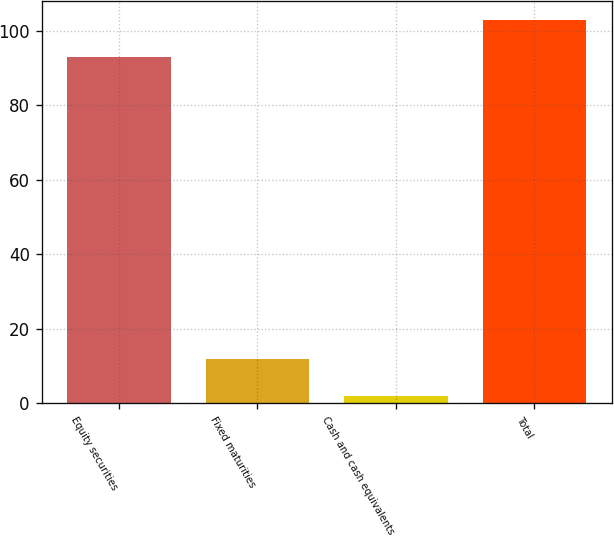Convert chart. <chart><loc_0><loc_0><loc_500><loc_500><bar_chart><fcel>Equity securities<fcel>Fixed maturities<fcel>Cash and cash equivalents<fcel>Total<nl><fcel>93<fcel>11.8<fcel>2<fcel>102.8<nl></chart> 